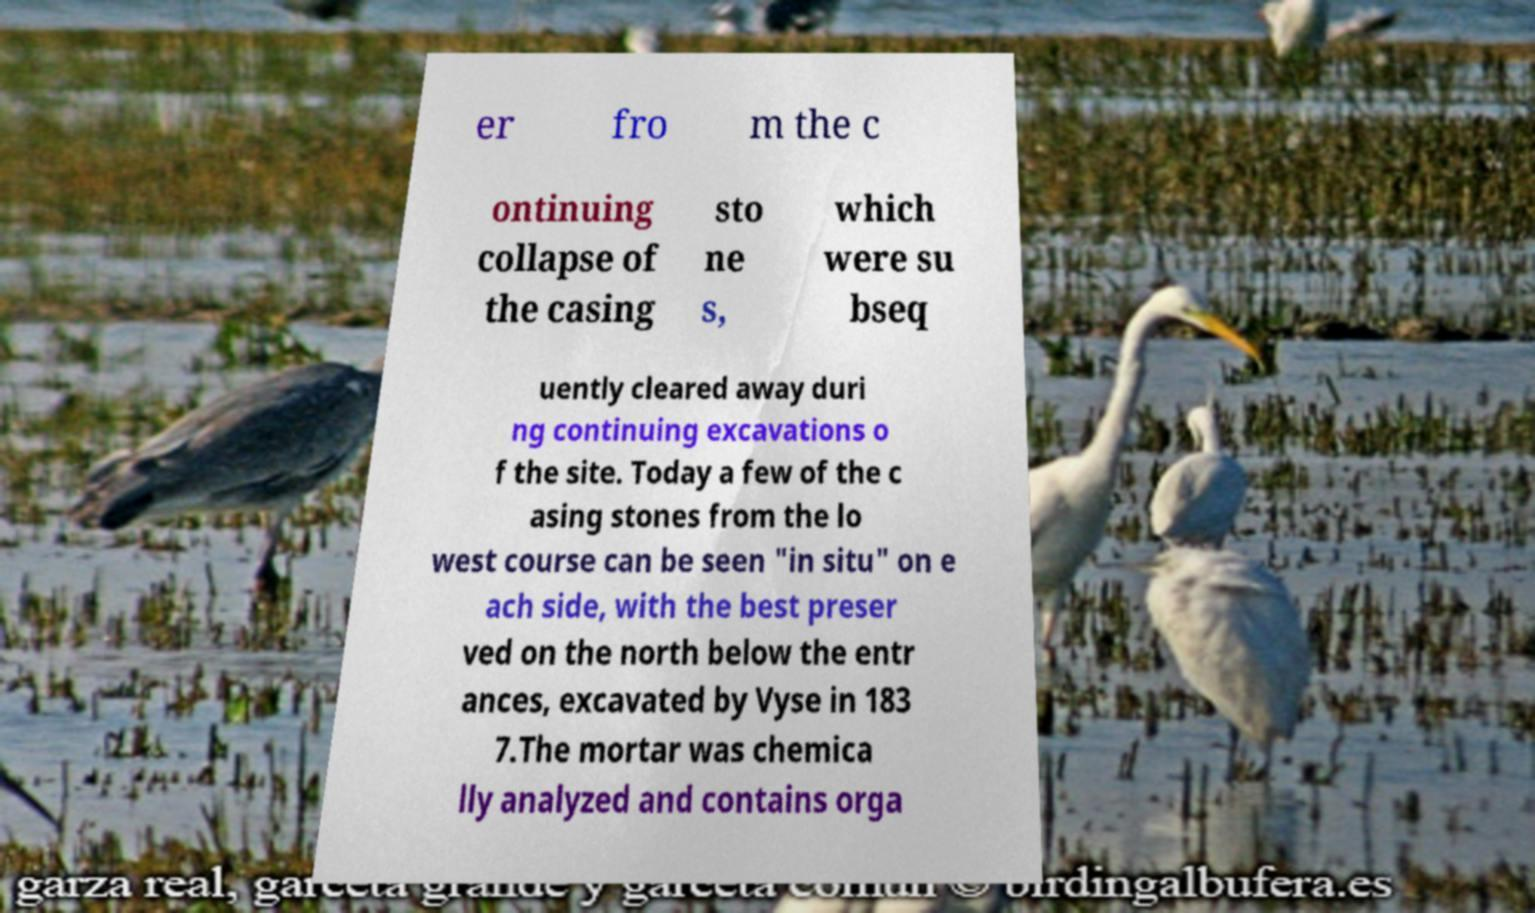I need the written content from this picture converted into text. Can you do that? er fro m the c ontinuing collapse of the casing sto ne s, which were su bseq uently cleared away duri ng continuing excavations o f the site. Today a few of the c asing stones from the lo west course can be seen "in situ" on e ach side, with the best preser ved on the north below the entr ances, excavated by Vyse in 183 7.The mortar was chemica lly analyzed and contains orga 